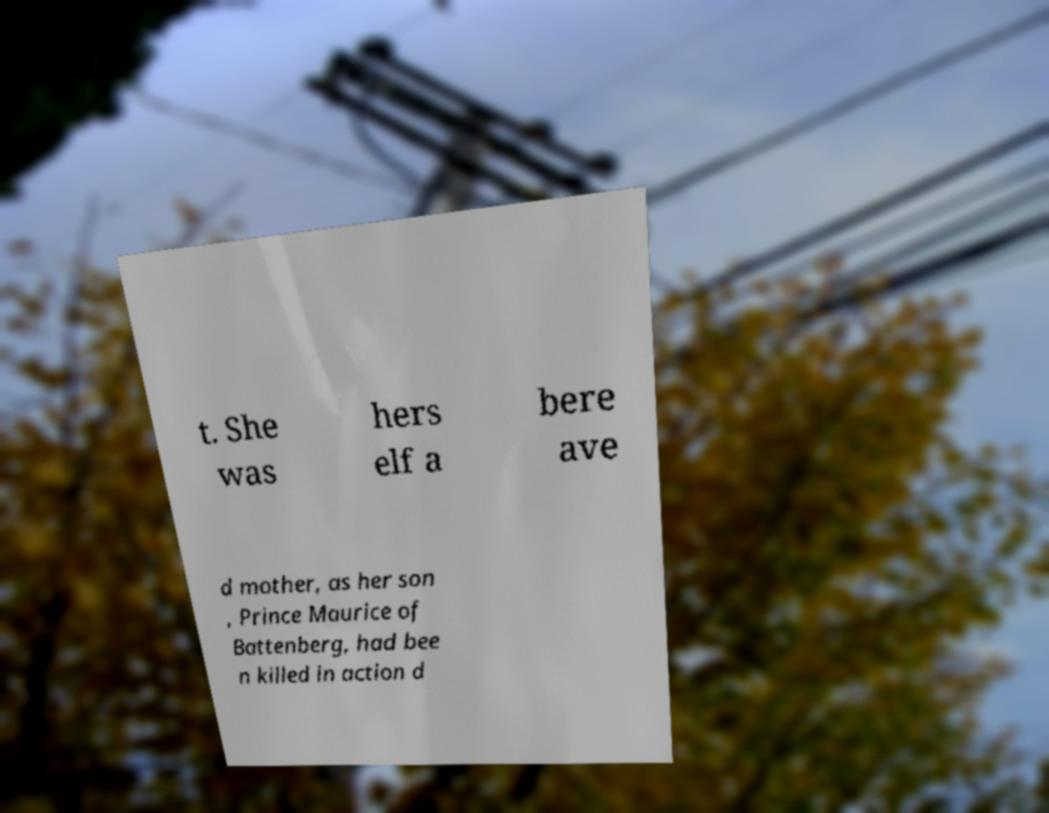I need the written content from this picture converted into text. Can you do that? t. She was hers elf a bere ave d mother, as her son , Prince Maurice of Battenberg, had bee n killed in action d 